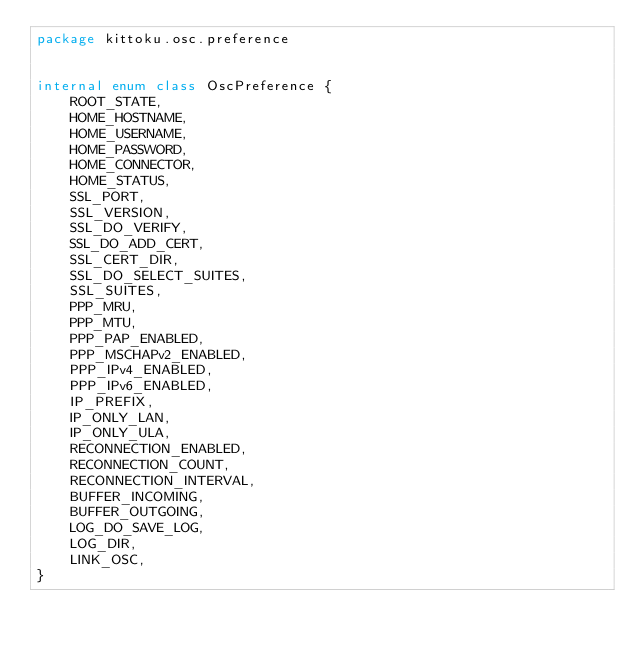<code> <loc_0><loc_0><loc_500><loc_500><_Kotlin_>package kittoku.osc.preference


internal enum class OscPreference {
    ROOT_STATE,
    HOME_HOSTNAME,
    HOME_USERNAME,
    HOME_PASSWORD,
    HOME_CONNECTOR,
    HOME_STATUS,
    SSL_PORT,
    SSL_VERSION,
    SSL_DO_VERIFY,
    SSL_DO_ADD_CERT,
    SSL_CERT_DIR,
    SSL_DO_SELECT_SUITES,
    SSL_SUITES,
    PPP_MRU,
    PPP_MTU,
    PPP_PAP_ENABLED,
    PPP_MSCHAPv2_ENABLED,
    PPP_IPv4_ENABLED,
    PPP_IPv6_ENABLED,
    IP_PREFIX,
    IP_ONLY_LAN,
    IP_ONLY_ULA,
    RECONNECTION_ENABLED,
    RECONNECTION_COUNT,
    RECONNECTION_INTERVAL,
    BUFFER_INCOMING,
    BUFFER_OUTGOING,
    LOG_DO_SAVE_LOG,
    LOG_DIR,
    LINK_OSC,
}
</code> 